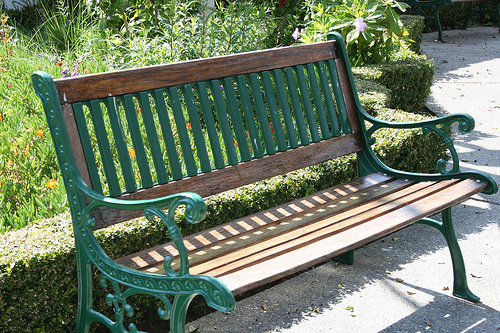How many benches are seen? 1 